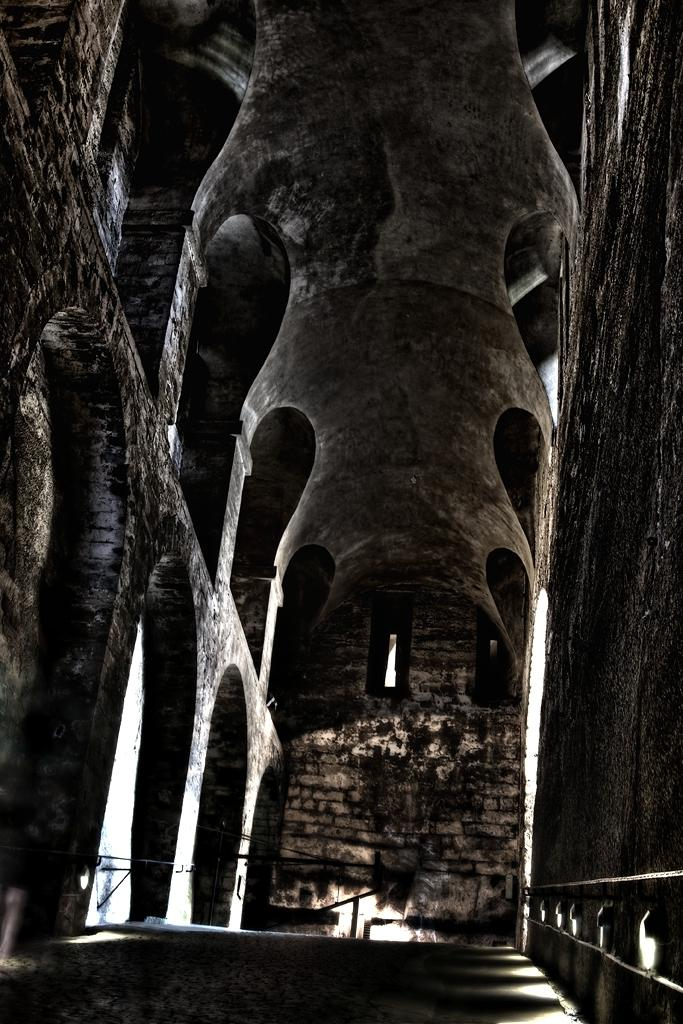What is the color scheme of the image? The image is black and white. What is the main subject in the image? There is a building in the middle of the image. What feature can be seen on the building? There are ventilation holes in the building. What is located at the bottom of the image? There is a wall at the bottom of the image. What type of bath is being taken in the image? There is no bath or any indication of bathing in the image. What process is being depicted in the image? The image does not show a specific process; it is a black and white image of a building with ventilation holes and a wall at the bottom. 